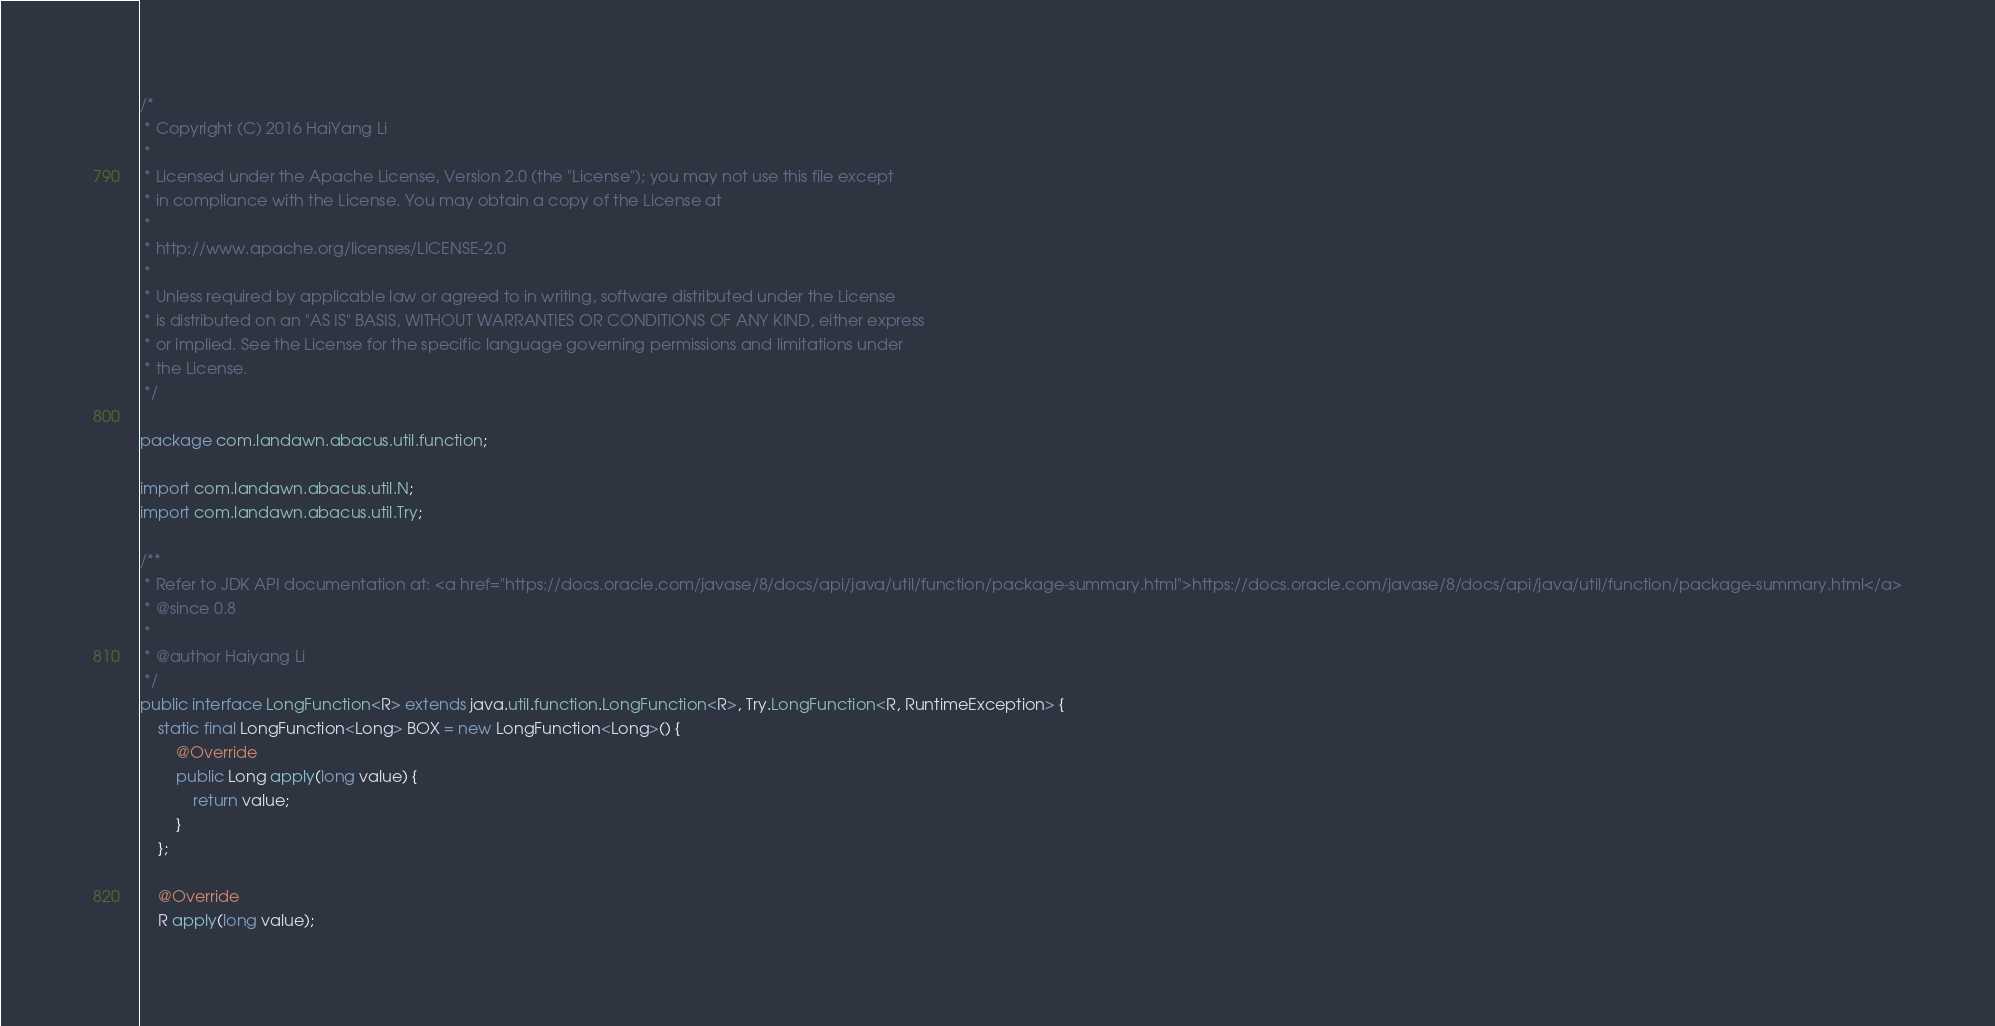<code> <loc_0><loc_0><loc_500><loc_500><_Java_>/*
 * Copyright (C) 2016 HaiYang Li
 *
 * Licensed under the Apache License, Version 2.0 (the "License"); you may not use this file except
 * in compliance with the License. You may obtain a copy of the License at
 *
 * http://www.apache.org/licenses/LICENSE-2.0
 *
 * Unless required by applicable law or agreed to in writing, software distributed under the License
 * is distributed on an "AS IS" BASIS, WITHOUT WARRANTIES OR CONDITIONS OF ANY KIND, either express
 * or implied. See the License for the specific language governing permissions and limitations under
 * the License.
 */

package com.landawn.abacus.util.function;

import com.landawn.abacus.util.N;
import com.landawn.abacus.util.Try;

/**
 * Refer to JDK API documentation at: <a href="https://docs.oracle.com/javase/8/docs/api/java/util/function/package-summary.html">https://docs.oracle.com/javase/8/docs/api/java/util/function/package-summary.html</a>
 * @since 0.8
 * 
 * @author Haiyang Li
 */
public interface LongFunction<R> extends java.util.function.LongFunction<R>, Try.LongFunction<R, RuntimeException> {
    static final LongFunction<Long> BOX = new LongFunction<Long>() {
        @Override
        public Long apply(long value) {
            return value;
        }
    };

    @Override
    R apply(long value);
</code> 